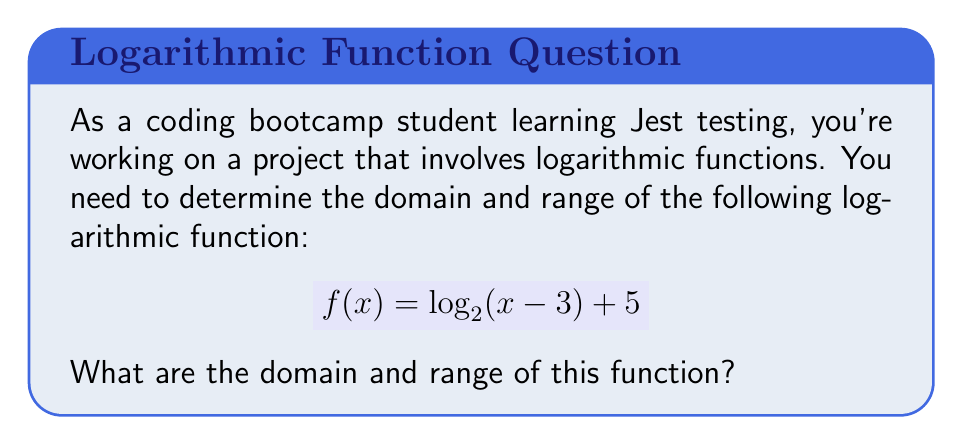What is the answer to this math problem? Let's approach this step-by-step:

1. Domain:
   For a logarithmic function $\log_a(x)$, the argument $x$ must be positive. So, we need:
   $$ x - 3 > 0 $$
   $$ x > 3 $$

   Therefore, the domain is all real numbers greater than 3.

2. Range:
   To find the range, let's consider the properties of logarithms:
   
   a) As $x$ approaches 3 from the right, $(x - 3)$ approaches 0 from the right.
      $\log_2$ of a very small positive number is a very large negative number.
      So, $f(x)$ can get arbitrarily close to negative infinity.
   
   b) As $x$ increases, $\log_2(x - 3)$ increases without bound.
      Adding 5 doesn't change this fact; $f(x)$ can get arbitrarily large.
   
   c) The logarithm function is continuous and strictly increasing.

   Therefore, the range is all real numbers.

This analysis aligns well with testing concepts. Just as we need to consider edge cases and all possible inputs when writing tests, we need to consider the behavior of the function as $x$ approaches its lower bound and as it goes to infinity.
Answer: Domain: $x > 3$ or $(3, \infty)$
Range: All real numbers or $(-\infty, \infty)$ 